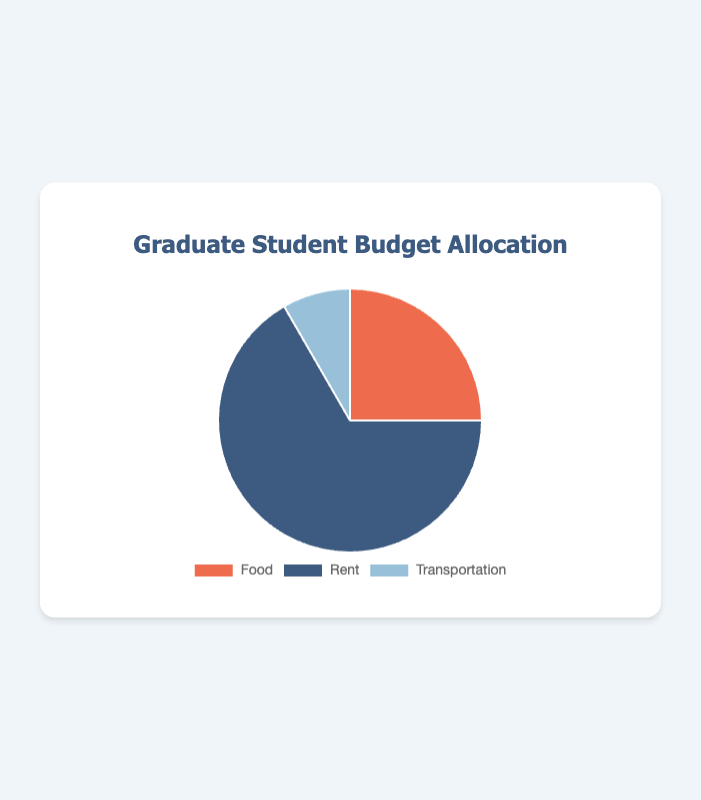What is the total budget allocated for all categories? Add up all the amounts for each category: Food ($300) + Rent ($800) + Transportation ($100). Thus, the total budget is $1200.
Answer: $1200 Which category has the highest budget allocation? Compare the amounts given for each category. Rent has the highest amount, which is $800.
Answer: Rent What's the percentage of the budget allocated to Food? Calculate the percentage by dividing the amount for Food by the total budget and then multiplying by 100: (300 / 1200) * 100 = 25%.
Answer: 25% How much more is allocated to Rent compared to Transportation? Subtract the amount allocated to Transportation from the amount allocated to Rent: $800 (Rent) - $100 (Transportation) = $700.
Answer: $700 Is the budget for Rent more than double the budget for Food? Double the budget for Food: 2 * $300 = $600. Then compare this value with the Rent allocation, which is $800. $800 is greater than $600.
Answer: Yes What are the colors used for each category in the pie chart? Food is orange, Rent is blue, and Transportation is light blue.
Answer: Orange for Food, Blue for Rent, Light Blue for Transportation Which category has the smallest budget allocation, and how much is it? Compare the amounts for each category and find the smallest one. Transportation has the smallest allocation with $100.
Answer: Transportation, $100 What's the difference between the budget for Food and Transportation? Subtract the amount for Transportation from the amount for Food: $300 (Food) - $100 (Transportation) = $200.
Answer: $200 Do Rent and Food together make up more than half of the total budget? Sum the amounts for Rent and Food: $800 (Rent) + $300 (Food) = $1100. Then check if this sum is more than half of the total budget: $1100 > 1200/2. Yes, $1100 is more than half of $1200.
Answer: Yes 